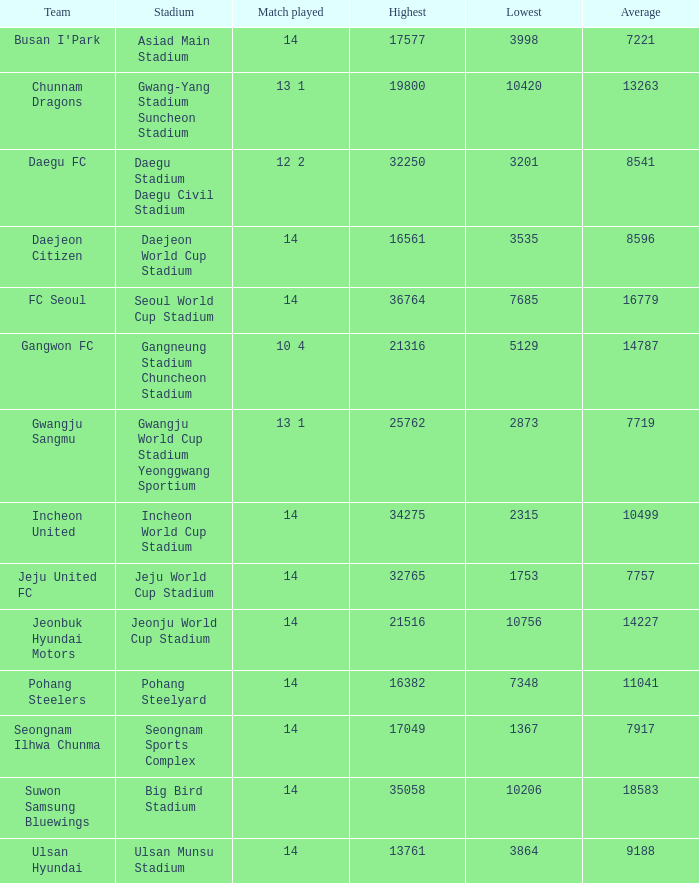Could you parse the entire table? {'header': ['Team', 'Stadium', 'Match played', 'Highest', 'Lowest', 'Average'], 'rows': [["Busan I'Park", 'Asiad Main Stadium', '14', '17577', '3998', '7221'], ['Chunnam Dragons', 'Gwang-Yang Stadium Suncheon Stadium', '13 1', '19800', '10420', '13263'], ['Daegu FC', 'Daegu Stadium Daegu Civil Stadium', '12 2', '32250', '3201', '8541'], ['Daejeon Citizen', 'Daejeon World Cup Stadium', '14', '16561', '3535', '8596'], ['FC Seoul', 'Seoul World Cup Stadium', '14', '36764', '7685', '16779'], ['Gangwon FC', 'Gangneung Stadium Chuncheon Stadium', '10 4', '21316', '5129', '14787'], ['Gwangju Sangmu', 'Gwangju World Cup Stadium Yeonggwang Sportium', '13 1', '25762', '2873', '7719'], ['Incheon United', 'Incheon World Cup Stadium', '14', '34275', '2315', '10499'], ['Jeju United FC', 'Jeju World Cup Stadium', '14', '32765', '1753', '7757'], ['Jeonbuk Hyundai Motors', 'Jeonju World Cup Stadium', '14', '21516', '10756', '14227'], ['Pohang Steelers', 'Pohang Steelyard', '14', '16382', '7348', '11041'], ['Seongnam Ilhwa Chunma', 'Seongnam Sports Complex', '14', '17049', '1367', '7917'], ['Suwon Samsung Bluewings', 'Big Bird Stadium', '14', '35058', '10206', '18583'], ['Ulsan Hyundai', 'Ulsan Munsu Stadium', '14', '13761', '3864', '9188']]} What is the minimum when pohang steel yard is the arena? 7348.0. 